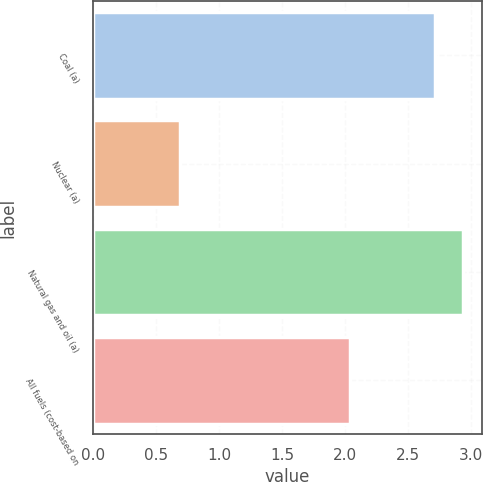Convert chart to OTSL. <chart><loc_0><loc_0><loc_500><loc_500><bar_chart><fcel>Coal (a)<fcel>Nuclear (a)<fcel>Natural gas and oil (a)<fcel>All fuels (cost-based on<nl><fcel>2.72<fcel>0.69<fcel>2.94<fcel>2.04<nl></chart> 